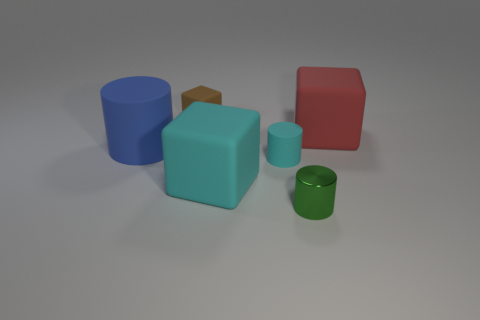There is a matte object right of the metal cylinder; what shape is it?
Your answer should be compact. Cube. Is the number of large cyan blocks less than the number of tiny cylinders?
Offer a terse response. Yes. Is there any other thing that has the same color as the metal object?
Ensure brevity in your answer.  No. What is the size of the matte object right of the small cyan rubber object?
Ensure brevity in your answer.  Large. Are there more rubber cubes than tiny brown cubes?
Offer a terse response. Yes. What material is the large cylinder?
Make the answer very short. Rubber. How many other things are there of the same material as the tiny cube?
Keep it short and to the point. 4. What number of metallic things are there?
Ensure brevity in your answer.  1. What is the material of the tiny green thing that is the same shape as the large blue rubber object?
Offer a terse response. Metal. Is the material of the large cube that is behind the big blue cylinder the same as the tiny green thing?
Your response must be concise. No. 